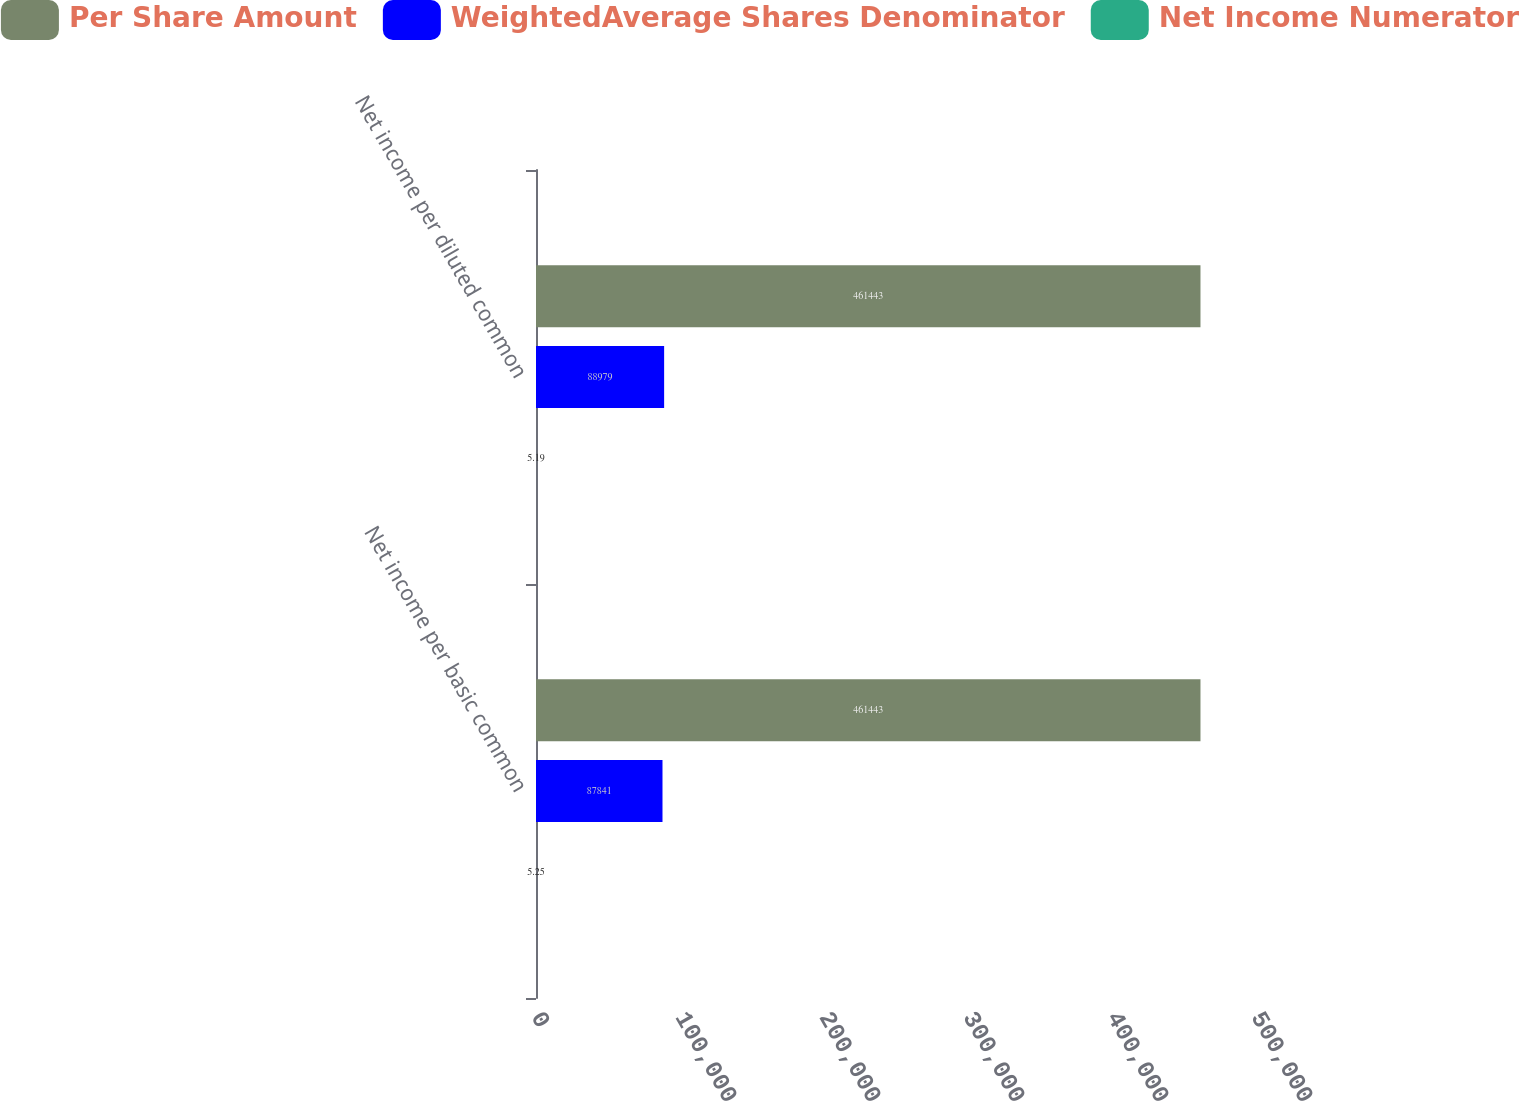Convert chart to OTSL. <chart><loc_0><loc_0><loc_500><loc_500><stacked_bar_chart><ecel><fcel>Net income per basic common<fcel>Net income per diluted common<nl><fcel>Per Share Amount<fcel>461443<fcel>461443<nl><fcel>WeightedAverage Shares Denominator<fcel>87841<fcel>88979<nl><fcel>Net Income Numerator<fcel>5.25<fcel>5.19<nl></chart> 